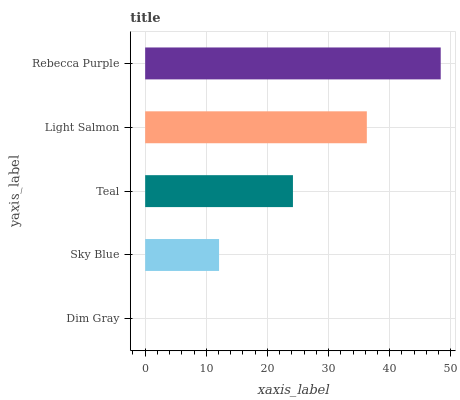Is Dim Gray the minimum?
Answer yes or no. Yes. Is Rebecca Purple the maximum?
Answer yes or no. Yes. Is Sky Blue the minimum?
Answer yes or no. No. Is Sky Blue the maximum?
Answer yes or no. No. Is Sky Blue greater than Dim Gray?
Answer yes or no. Yes. Is Dim Gray less than Sky Blue?
Answer yes or no. Yes. Is Dim Gray greater than Sky Blue?
Answer yes or no. No. Is Sky Blue less than Dim Gray?
Answer yes or no. No. Is Teal the high median?
Answer yes or no. Yes. Is Teal the low median?
Answer yes or no. Yes. Is Sky Blue the high median?
Answer yes or no. No. Is Light Salmon the low median?
Answer yes or no. No. 